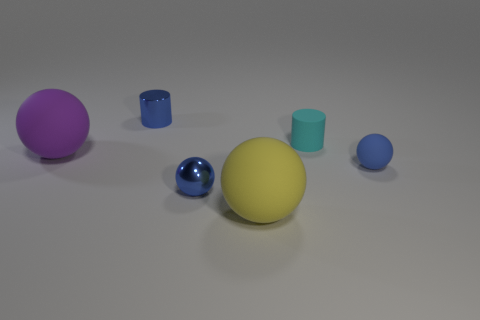Subtract all red spheres. Subtract all yellow cylinders. How many spheres are left? 4 Add 3 purple things. How many objects exist? 9 Subtract all balls. How many objects are left? 2 Subtract 0 brown cubes. How many objects are left? 6 Subtract all rubber cylinders. Subtract all blue rubber balls. How many objects are left? 4 Add 5 purple rubber balls. How many purple rubber balls are left? 6 Add 6 cylinders. How many cylinders exist? 8 